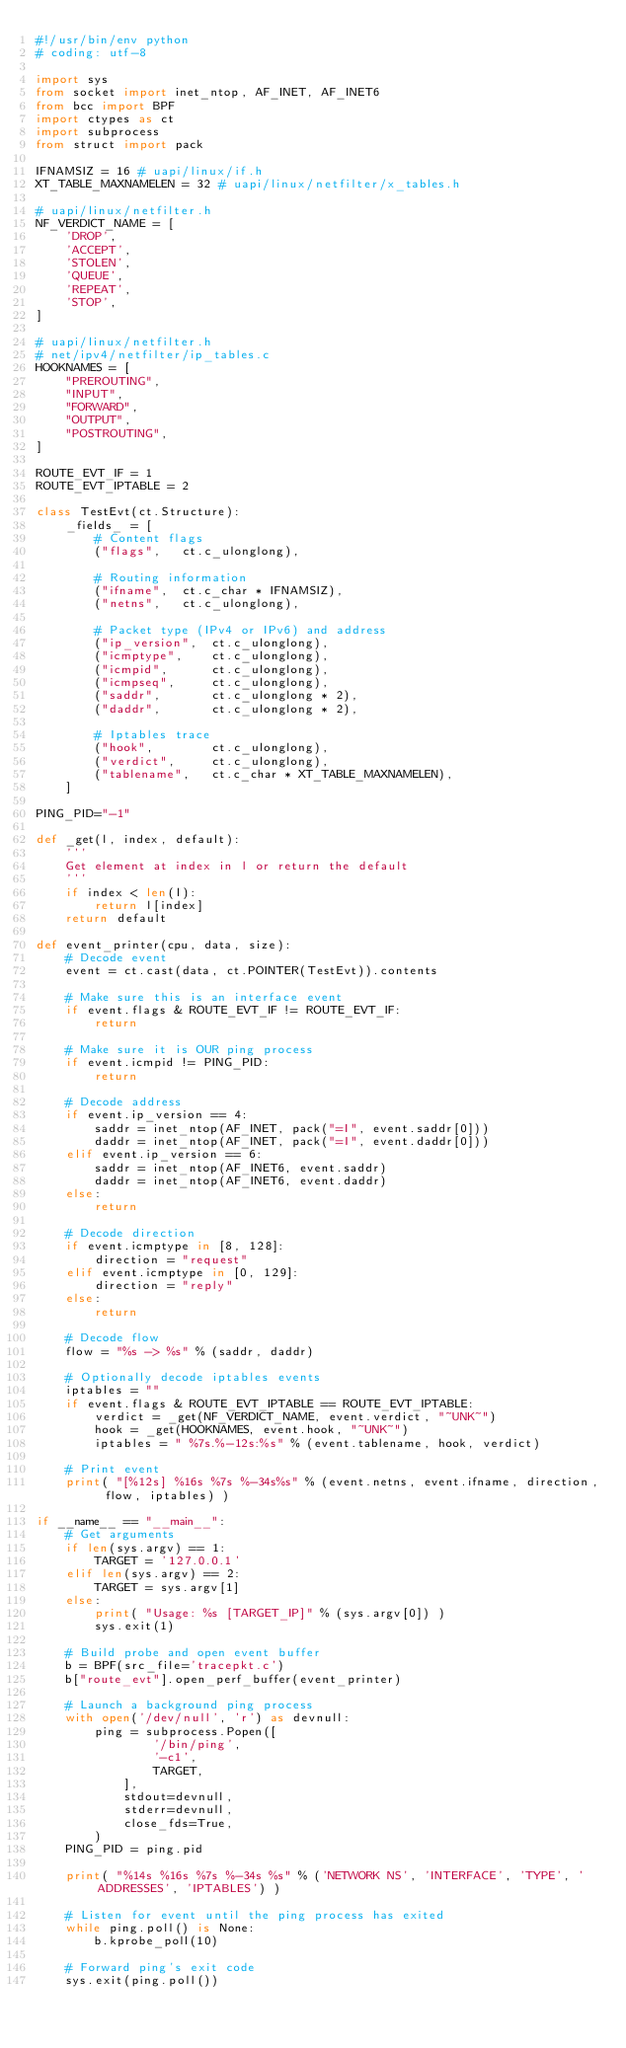Convert code to text. <code><loc_0><loc_0><loc_500><loc_500><_Python_>#!/usr/bin/env python
# coding: utf-8

import sys
from socket import inet_ntop, AF_INET, AF_INET6
from bcc import BPF
import ctypes as ct
import subprocess
from struct import pack

IFNAMSIZ = 16 # uapi/linux/if.h
XT_TABLE_MAXNAMELEN = 32 # uapi/linux/netfilter/x_tables.h

# uapi/linux/netfilter.h
NF_VERDICT_NAME = [
    'DROP',
    'ACCEPT',
    'STOLEN',
    'QUEUE',
    'REPEAT',
    'STOP',
]

# uapi/linux/netfilter.h
# net/ipv4/netfilter/ip_tables.c
HOOKNAMES = [
    "PREROUTING",
    "INPUT",
    "FORWARD",
    "OUTPUT",
    "POSTROUTING",
]

ROUTE_EVT_IF = 1
ROUTE_EVT_IPTABLE = 2

class TestEvt(ct.Structure):
    _fields_ = [
        # Content flags
        ("flags",   ct.c_ulonglong),

        # Routing information
        ("ifname",  ct.c_char * IFNAMSIZ),
        ("netns",   ct.c_ulonglong),

        # Packet type (IPv4 or IPv6) and address
        ("ip_version",  ct.c_ulonglong),
        ("icmptype",    ct.c_ulonglong),
        ("icmpid",      ct.c_ulonglong),
        ("icmpseq",     ct.c_ulonglong),
        ("saddr",       ct.c_ulonglong * 2),
        ("daddr",       ct.c_ulonglong * 2),

        # Iptables trace
        ("hook",        ct.c_ulonglong),
        ("verdict",     ct.c_ulonglong),
        ("tablename",   ct.c_char * XT_TABLE_MAXNAMELEN),
    ]

PING_PID="-1"

def _get(l, index, default):
    '''
    Get element at index in l or return the default
    '''
    if index < len(l):
        return l[index]
    return default

def event_printer(cpu, data, size):
    # Decode event
    event = ct.cast(data, ct.POINTER(TestEvt)).contents

    # Make sure this is an interface event
    if event.flags & ROUTE_EVT_IF != ROUTE_EVT_IF:
        return

    # Make sure it is OUR ping process
    if event.icmpid != PING_PID:
        return

    # Decode address
    if event.ip_version == 4:
        saddr = inet_ntop(AF_INET, pack("=I", event.saddr[0]))
        daddr = inet_ntop(AF_INET, pack("=I", event.daddr[0]))
    elif event.ip_version == 6:
        saddr = inet_ntop(AF_INET6, event.saddr)
        daddr = inet_ntop(AF_INET6, event.daddr)
    else:
        return

    # Decode direction
    if event.icmptype in [8, 128]:
        direction = "request"
    elif event.icmptype in [0, 129]:
        direction = "reply"
    else:
        return

    # Decode flow
    flow = "%s -> %s" % (saddr, daddr)

    # Optionally decode iptables events
    iptables = ""
    if event.flags & ROUTE_EVT_IPTABLE == ROUTE_EVT_IPTABLE:
        verdict = _get(NF_VERDICT_NAME, event.verdict, "~UNK~")
        hook = _get(HOOKNAMES, event.hook, "~UNK~")
        iptables = " %7s.%-12s:%s" % (event.tablename, hook, verdict)

    # Print event
    print( "[%12s] %16s %7s %-34s%s" % (event.netns, event.ifname, direction, flow, iptables) )

if __name__ == "__main__":
    # Get arguments
    if len(sys.argv) == 1:
        TARGET = '127.0.0.1'
    elif len(sys.argv) == 2:
        TARGET = sys.argv[1]
    else:
        print( "Usage: %s [TARGET_IP]" % (sys.argv[0]) )
        sys.exit(1)

    # Build probe and open event buffer
    b = BPF(src_file='tracepkt.c')
    b["route_evt"].open_perf_buffer(event_printer)

    # Launch a background ping process
    with open('/dev/null', 'r') as devnull:
        ping = subprocess.Popen([
                '/bin/ping',
                '-c1',
                TARGET,
            ],
            stdout=devnull,
            stderr=devnull,
            close_fds=True,
        )
    PING_PID = ping.pid

    print( "%14s %16s %7s %-34s %s" % ('NETWORK NS', 'INTERFACE', 'TYPE', 'ADDRESSES', 'IPTABLES') )

    # Listen for event until the ping process has exited
    while ping.poll() is None:
        b.kprobe_poll(10)

    # Forward ping's exit code
    sys.exit(ping.poll())
</code> 